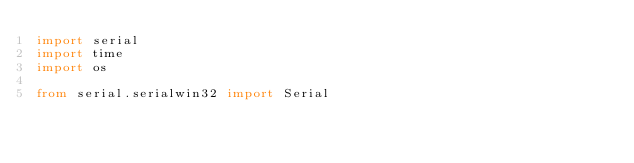Convert code to text. <code><loc_0><loc_0><loc_500><loc_500><_Python_>import serial 
import time
import os

from serial.serialwin32 import Serial




</code> 